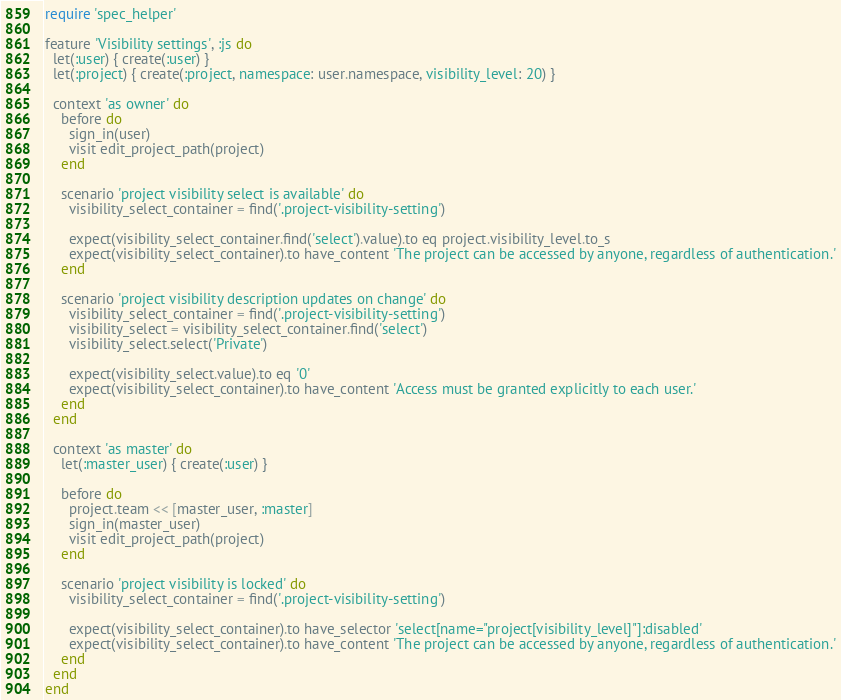Convert code to text. <code><loc_0><loc_0><loc_500><loc_500><_Ruby_>require 'spec_helper'

feature 'Visibility settings', :js do
  let(:user) { create(:user) }
  let(:project) { create(:project, namespace: user.namespace, visibility_level: 20) }

  context 'as owner' do
    before do
      sign_in(user)
      visit edit_project_path(project)
    end

    scenario 'project visibility select is available' do
      visibility_select_container = find('.project-visibility-setting')

      expect(visibility_select_container.find('select').value).to eq project.visibility_level.to_s
      expect(visibility_select_container).to have_content 'The project can be accessed by anyone, regardless of authentication.'
    end

    scenario 'project visibility description updates on change' do
      visibility_select_container = find('.project-visibility-setting')
      visibility_select = visibility_select_container.find('select')
      visibility_select.select('Private')

      expect(visibility_select.value).to eq '0'
      expect(visibility_select_container).to have_content 'Access must be granted explicitly to each user.'
    end
  end

  context 'as master' do
    let(:master_user) { create(:user) }

    before do
      project.team << [master_user, :master]
      sign_in(master_user)
      visit edit_project_path(project)
    end

    scenario 'project visibility is locked' do
      visibility_select_container = find('.project-visibility-setting')

      expect(visibility_select_container).to have_selector 'select[name="project[visibility_level]"]:disabled'
      expect(visibility_select_container).to have_content 'The project can be accessed by anyone, regardless of authentication.'
    end
  end
end
</code> 